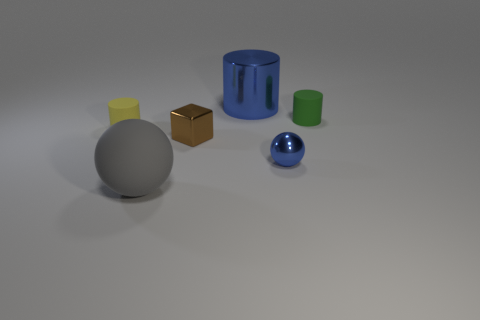Add 1 green metallic things. How many objects exist? 7 Subtract all spheres. How many objects are left? 4 Subtract 1 blue spheres. How many objects are left? 5 Subtract all large gray rubber balls. Subtract all red cubes. How many objects are left? 5 Add 3 green cylinders. How many green cylinders are left? 4 Add 1 yellow rubber things. How many yellow rubber things exist? 2 